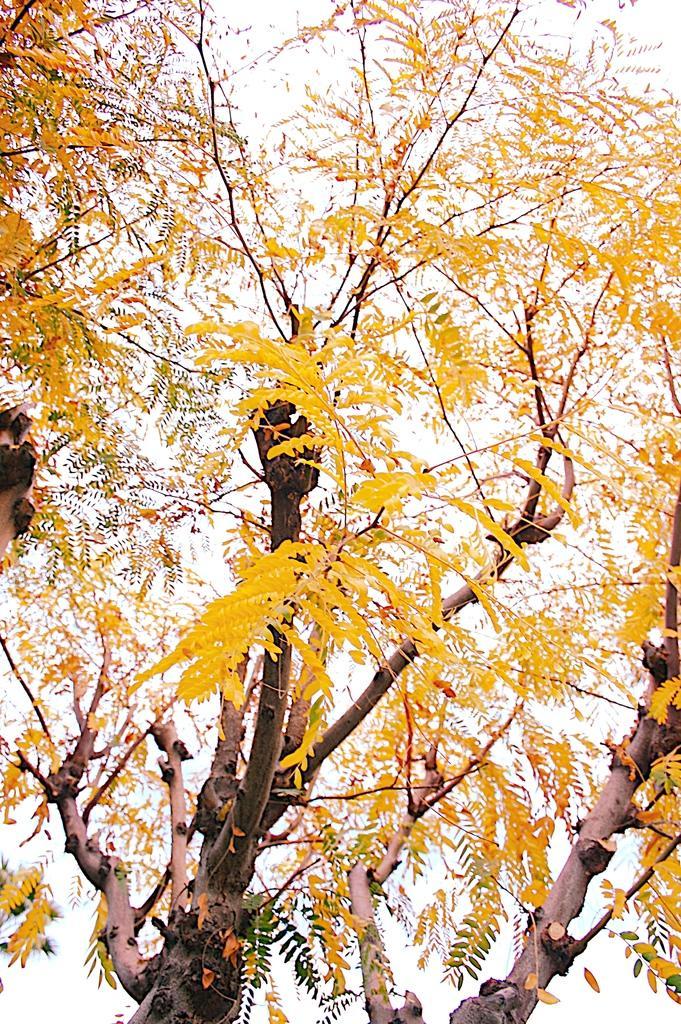Describe this image in one or two sentences. In this image we can see trees and sky. 